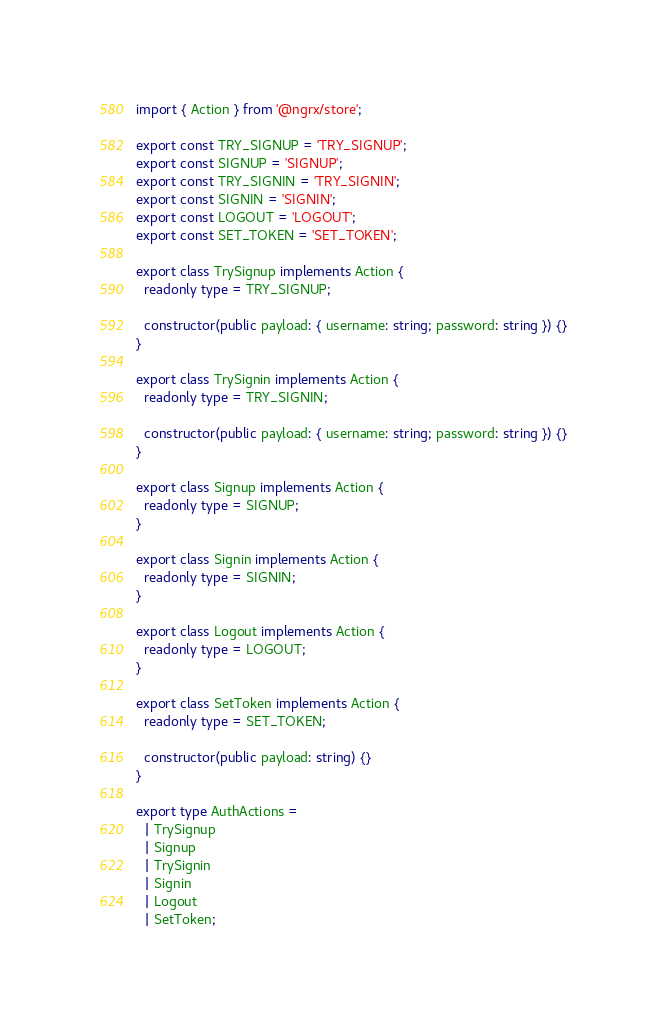<code> <loc_0><loc_0><loc_500><loc_500><_TypeScript_>import { Action } from '@ngrx/store';

export const TRY_SIGNUP = 'TRY_SIGNUP';
export const SIGNUP = 'SIGNUP';
export const TRY_SIGNIN = 'TRY_SIGNIN';
export const SIGNIN = 'SIGNIN';
export const LOGOUT = 'LOGOUT';
export const SET_TOKEN = 'SET_TOKEN';

export class TrySignup implements Action {
  readonly type = TRY_SIGNUP;

  constructor(public payload: { username: string; password: string }) {}
}

export class TrySignin implements Action {
  readonly type = TRY_SIGNIN;

  constructor(public payload: { username: string; password: string }) {}
}

export class Signup implements Action {
  readonly type = SIGNUP;
}

export class Signin implements Action {
  readonly type = SIGNIN;
}

export class Logout implements Action {
  readonly type = LOGOUT;
}

export class SetToken implements Action {
  readonly type = SET_TOKEN;

  constructor(public payload: string) {}
}

export type AuthActions =
  | TrySignup
  | Signup
  | TrySignin
  | Signin
  | Logout
  | SetToken;
</code> 